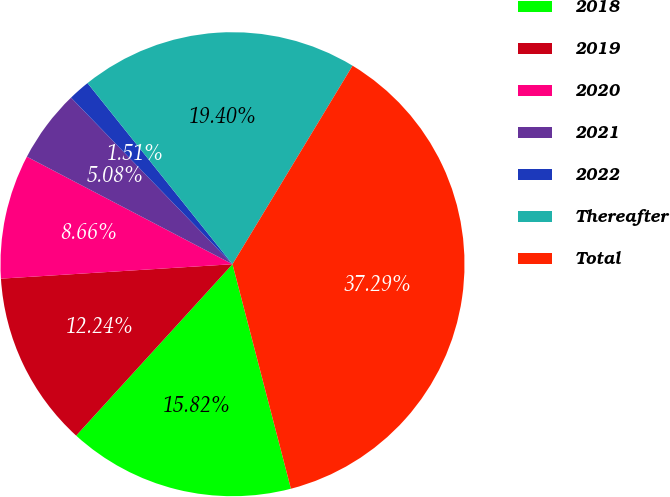Convert chart. <chart><loc_0><loc_0><loc_500><loc_500><pie_chart><fcel>2018<fcel>2019<fcel>2020<fcel>2021<fcel>2022<fcel>Thereafter<fcel>Total<nl><fcel>15.82%<fcel>12.24%<fcel>8.66%<fcel>5.08%<fcel>1.51%<fcel>19.4%<fcel>37.29%<nl></chart> 